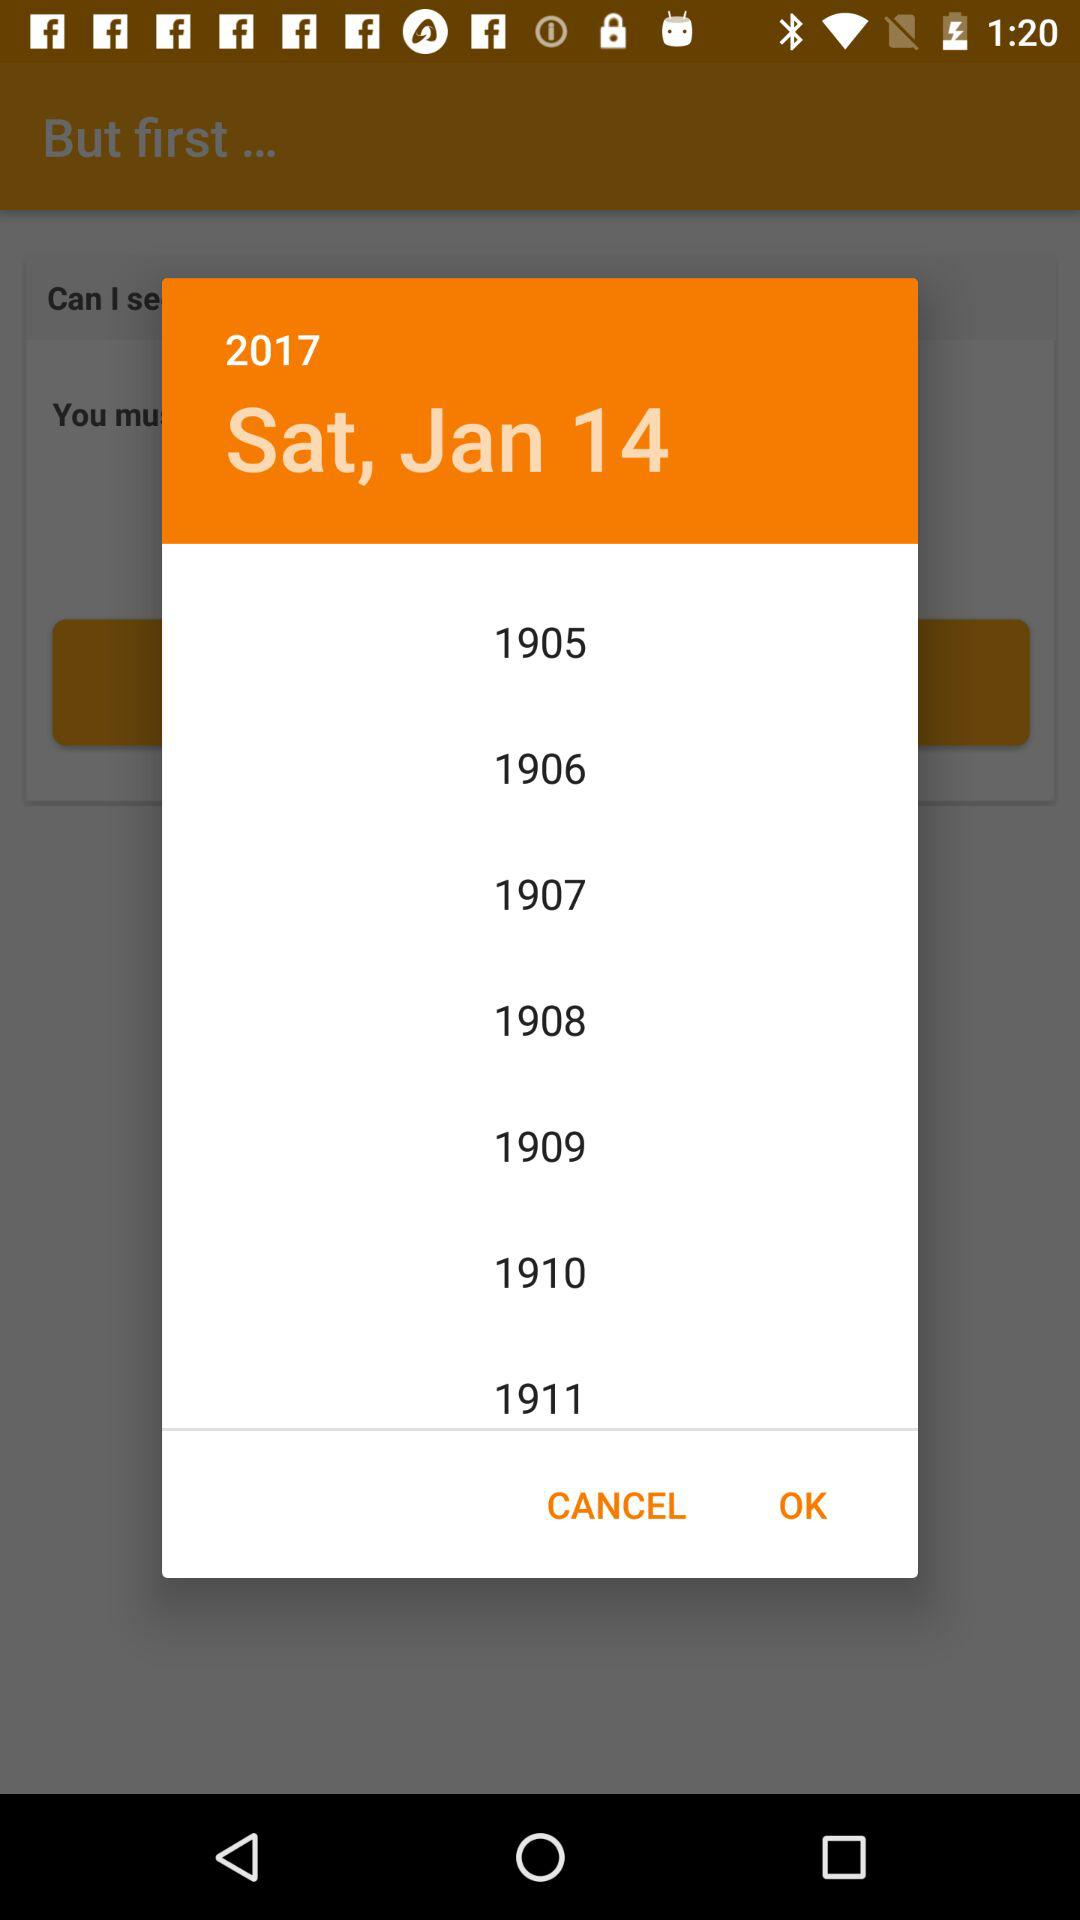What is the day on Jan 14, 2017? The day is Saturday. 